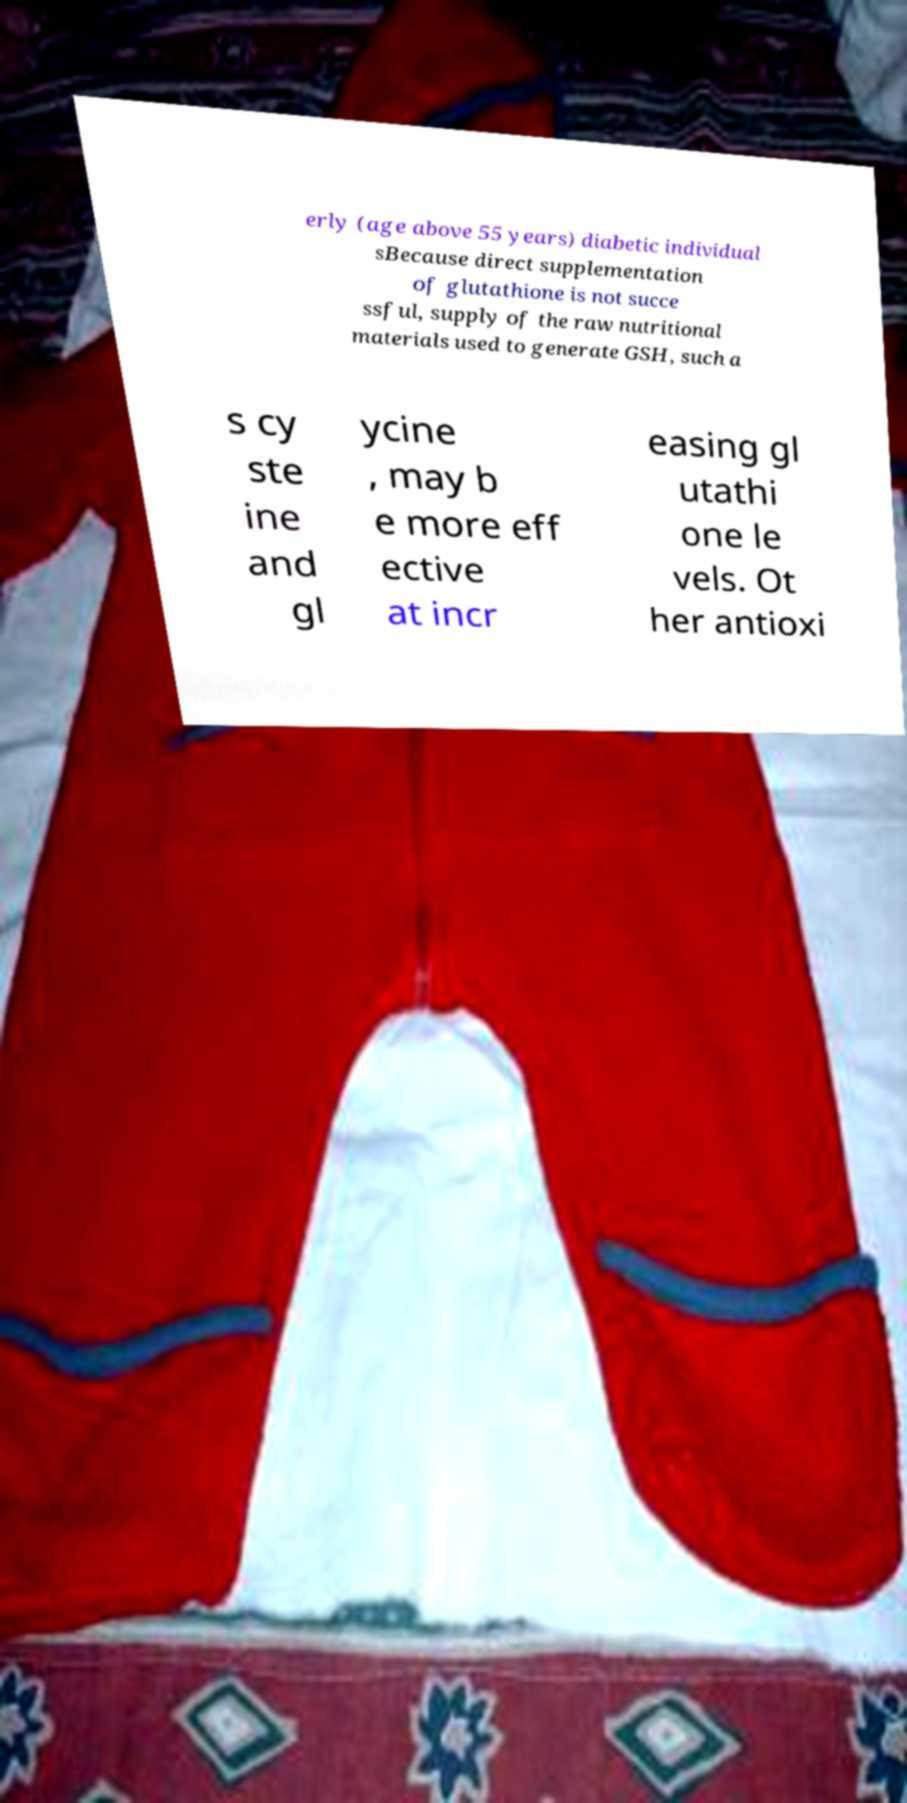What messages or text are displayed in this image? I need them in a readable, typed format. erly (age above 55 years) diabetic individual sBecause direct supplementation of glutathione is not succe ssful, supply of the raw nutritional materials used to generate GSH, such a s cy ste ine and gl ycine , may b e more eff ective at incr easing gl utathi one le vels. Ot her antioxi 